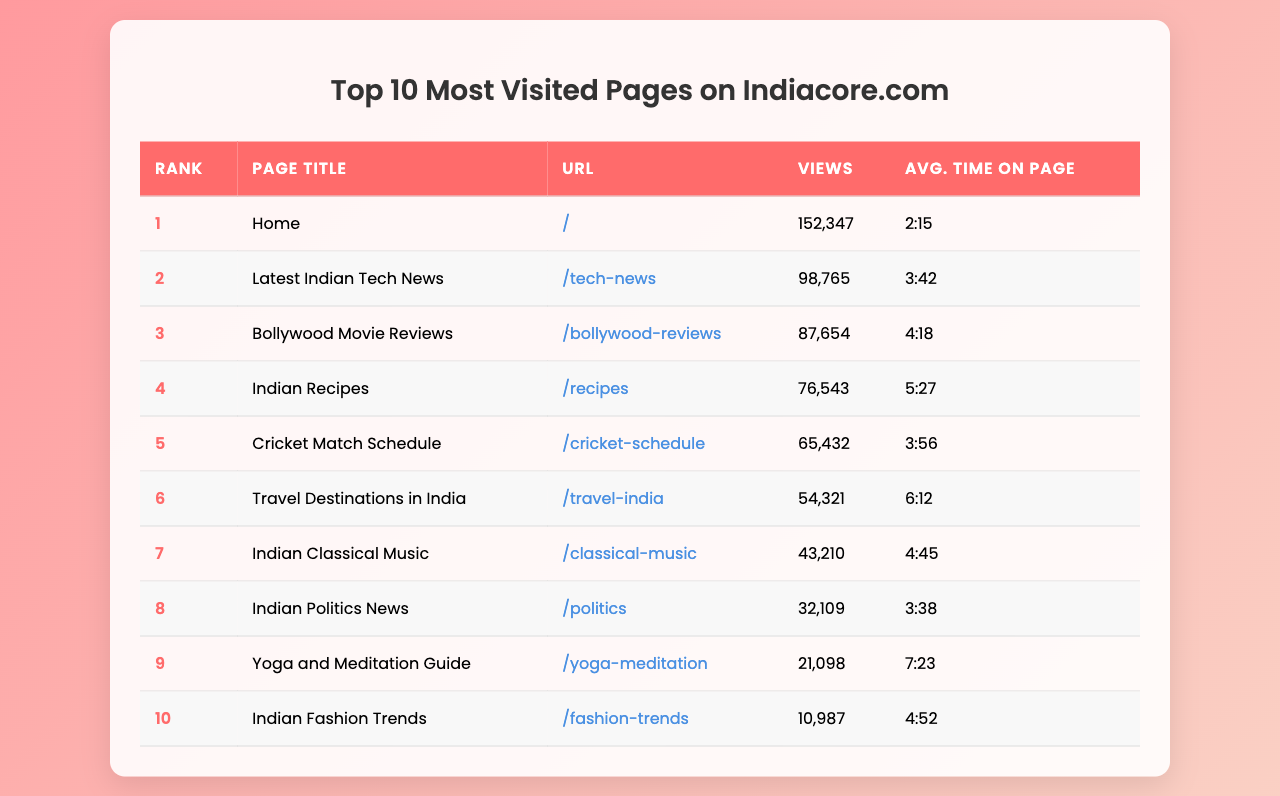What is the most visited page on Indiacore.com? The table shows the "Home" page with the highest views of 152,347.
Answer: Home How many views did the "Indian Recipes" page receive? According to the table, "Indian Recipes" had 76,543 views.
Answer: 76,543 What is the average time spent on the "Yoga and Meditation Guide" page? The table indicates that the average time spent on this page is 7 minutes and 23 seconds.
Answer: 7:23 Which page has the least views among the top 10? The "Indian Fashion Trends" page has the least views of 10,987, based on the data.
Answer: Indian Fashion Trends How many more views did the "Travel Destinations in India" page have compared to the "Cricket Match Schedule" page? "Travel Destinations in India" received 54,321 views, while "Cricket Match Schedule" received 65,432 views. The difference is 65,432 - 54,321 = 11,111 views.
Answer: 11,111 What is the total number of views for the top three pages combined? The views for the top three pages are Home (152,347), Tech News (98,765), and Bollywood Reviews (87,654). Summing these gives 152,347 + 98,765 + 87,654 = 338,766.
Answer: 338,766 Is the average time on the "Bollywood Movie Reviews" page greater than that on the "Cricket Match Schedule" page? The "Bollywood Movie Reviews" has an average time of 4 minutes and 18 seconds, while the "Cricket Match Schedule" has 3 minutes and 56 seconds. Since 4:18 is more than 3:56, the statement is true.
Answer: Yes What percentage of the total views (for the top 10 pages) does the "Latest Indian Tech News" page contribute? The total views for all pages are 652,047 (sum of all views), and "Latest Indian Tech News" has 98,765 views. The percentage is (98,765 / 652,047) * 100 ≈ 15.1%.
Answer: 15.1% Which page has the highest average time on page, and what is that time? The "Yoga and Meditation Guide" page has the highest average time of 7 minutes and 23 seconds.
Answer: Yoga and Meditation Guide, 7:23 Are there more views for the "Indian Classical Music" page or the "Indian Politics News" page, and by how much? "Indian Classical Music" has 43,210 views, while "Indian Politics News" has 32,109 views. The difference is 43,210 - 32,109 = 11,101 views.
Answer: 11,101 more views for Indian Classical Music 